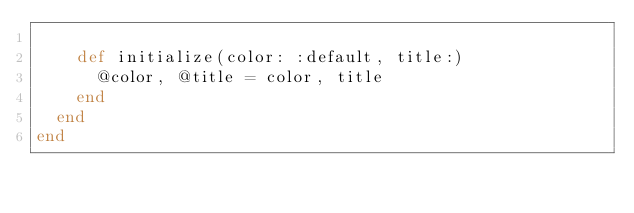<code> <loc_0><loc_0><loc_500><loc_500><_Ruby_>
    def initialize(color: :default, title:)
      @color, @title = color, title
    end
  end
end
</code> 